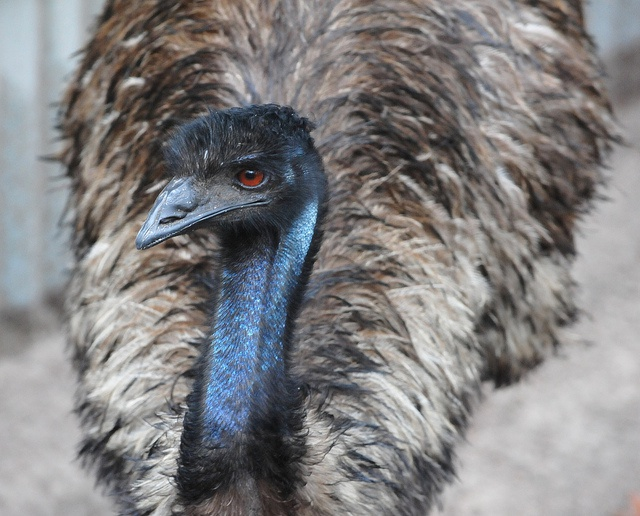Describe the objects in this image and their specific colors. I can see a bird in gray, darkgray, and black tones in this image. 